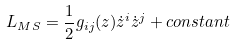Convert formula to latex. <formula><loc_0><loc_0><loc_500><loc_500>L _ { M S } = \frac { 1 } { 2 } g _ { i j } ( z ) \dot { z } ^ { i } \dot { z } ^ { j } + c o n s t a n t</formula> 